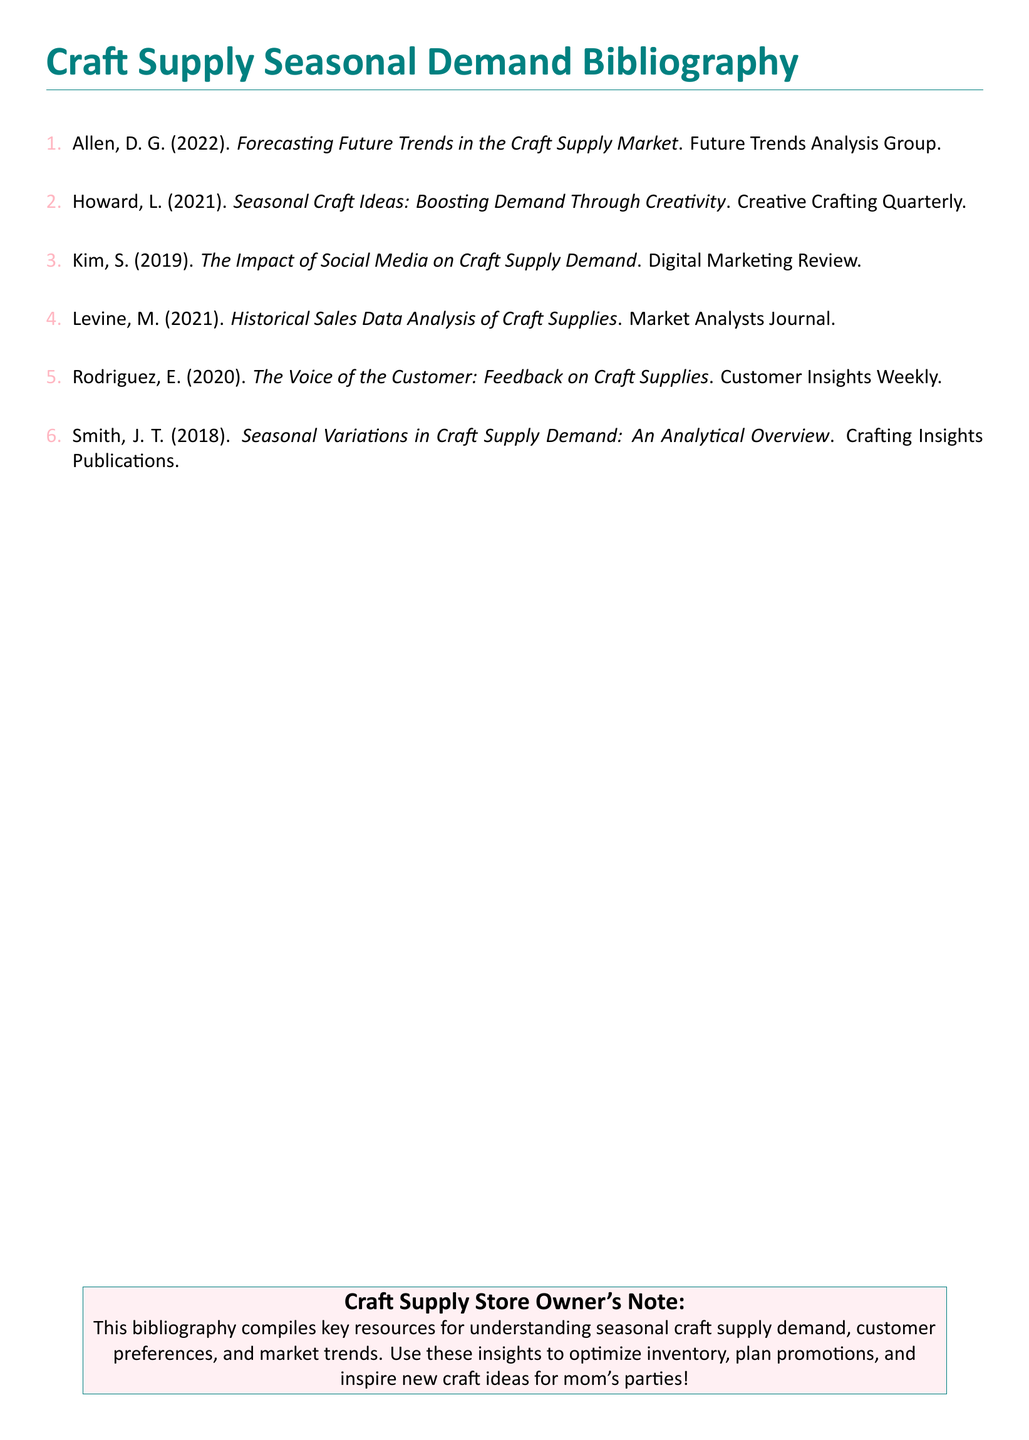What is the title of the first source listed? The title is found in the first item of the bibliography, which is "Forecasting Future Trends in the Craft Supply Market."
Answer: Forecasting Future Trends in the Craft Supply Market Who is the author of the article on historical sales data? The author's name is indicated in the fourth item of the bibliography.
Answer: Levine What year was the article about customer feedback published? The publication year can be found in the fifth source listed.
Answer: 2020 Which publication covers seasonal craft ideas? This information can be retrieved from the second item in the bibliography.
Answer: Creative Crafting Quarterly How many sources are in the bibliography? The number of sources is indicated by the enumeration in the document.
Answer: 6 What color is used for the section titles? The colors used can be inferred from the document specifications.
Answer: Craft teal What type of insights does the Craft Supply Store Owner's Note aim to provide? The note mentions optimizing inventory, planning promotions, and inspiring craft ideas.
Answer: Market trends What aspect of craft supply demand is analyzed by Smith? This information is in the sixth source of the bibliography.
Answer: Seasonal variations Which journal published an article about the impact of social media on craft supply demand? The publication title is listed with the author's work on social media impact.
Answer: Digital Marketing Review 